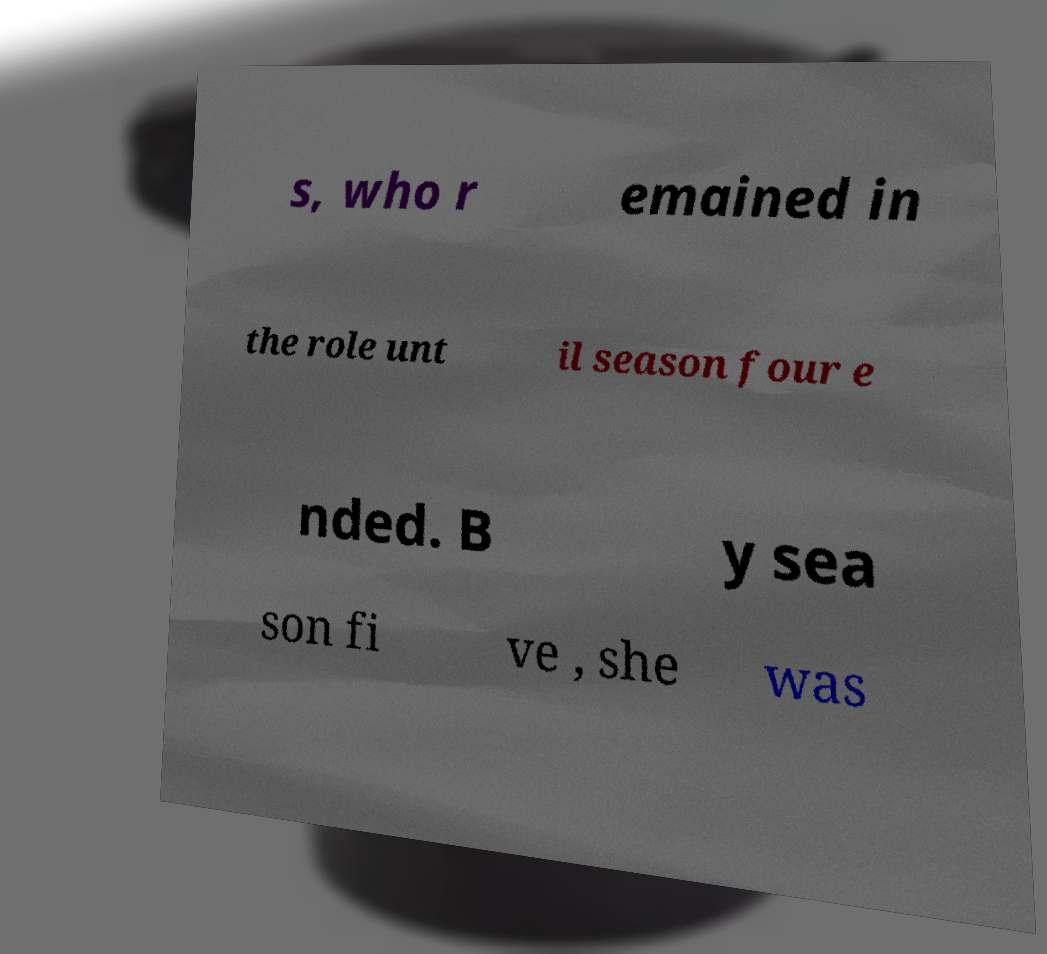For documentation purposes, I need the text within this image transcribed. Could you provide that? s, who r emained in the role unt il season four e nded. B y sea son fi ve , she was 